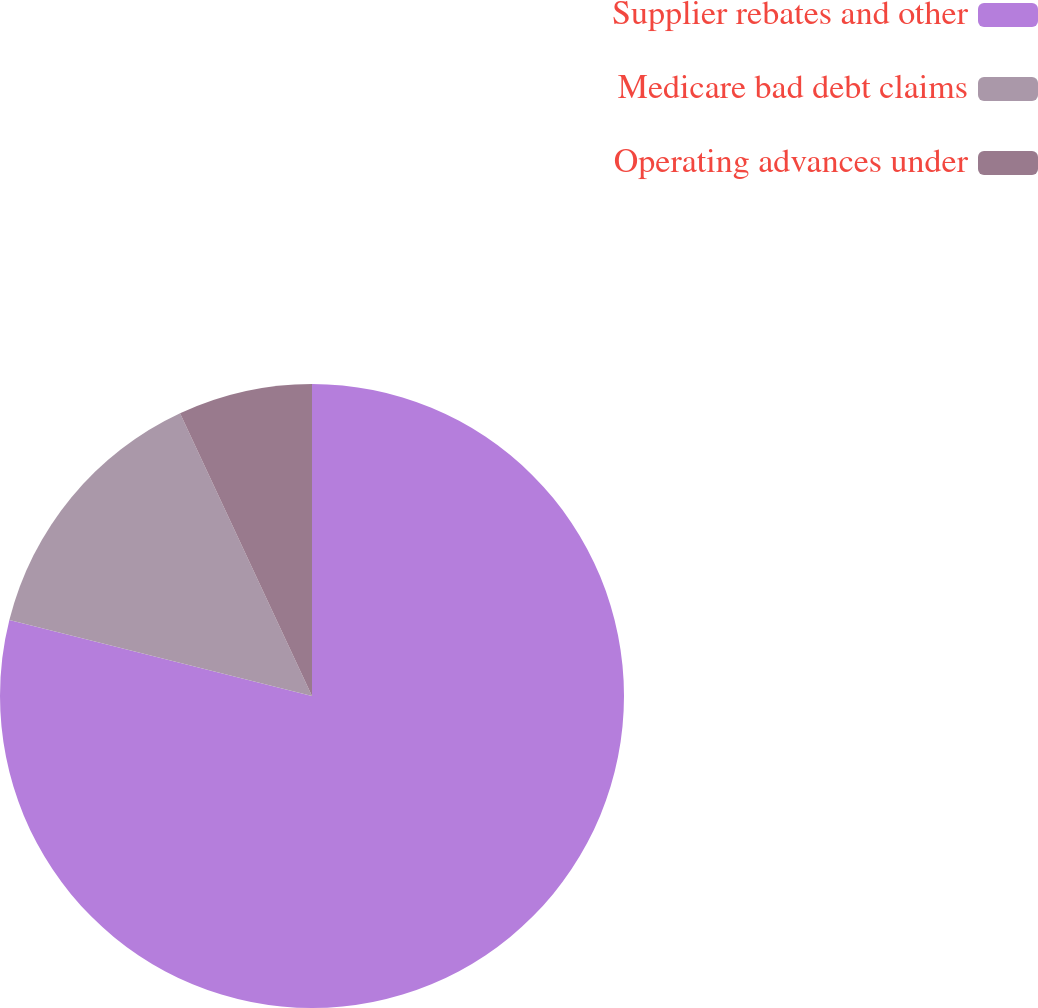<chart> <loc_0><loc_0><loc_500><loc_500><pie_chart><fcel>Supplier rebates and other<fcel>Medicare bad debt claims<fcel>Operating advances under<nl><fcel>78.91%<fcel>14.14%<fcel>6.95%<nl></chart> 